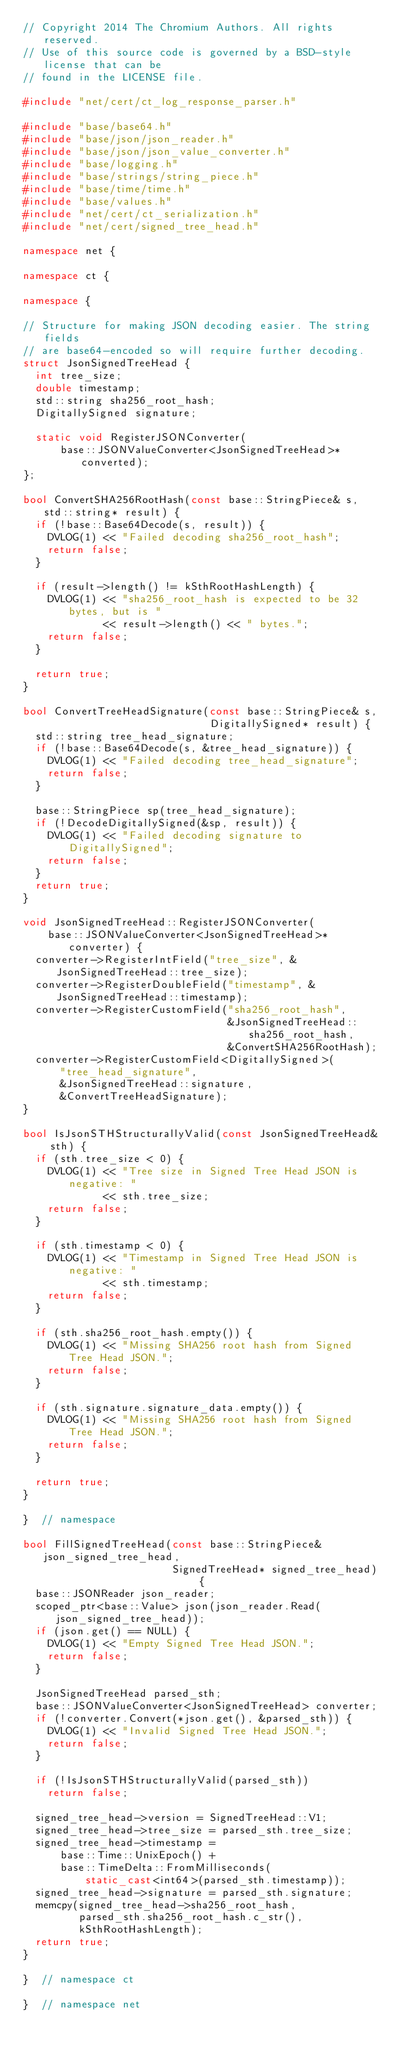Convert code to text. <code><loc_0><loc_0><loc_500><loc_500><_C++_>// Copyright 2014 The Chromium Authors. All rights reserved.
// Use of this source code is governed by a BSD-style license that can be
// found in the LICENSE file.

#include "net/cert/ct_log_response_parser.h"

#include "base/base64.h"
#include "base/json/json_reader.h"
#include "base/json/json_value_converter.h"
#include "base/logging.h"
#include "base/strings/string_piece.h"
#include "base/time/time.h"
#include "base/values.h"
#include "net/cert/ct_serialization.h"
#include "net/cert/signed_tree_head.h"

namespace net {

namespace ct {

namespace {

// Structure for making JSON decoding easier. The string fields
// are base64-encoded so will require further decoding.
struct JsonSignedTreeHead {
  int tree_size;
  double timestamp;
  std::string sha256_root_hash;
  DigitallySigned signature;

  static void RegisterJSONConverter(
      base::JSONValueConverter<JsonSignedTreeHead>* converted);
};

bool ConvertSHA256RootHash(const base::StringPiece& s, std::string* result) {
  if (!base::Base64Decode(s, result)) {
    DVLOG(1) << "Failed decoding sha256_root_hash";
    return false;
  }

  if (result->length() != kSthRootHashLength) {
    DVLOG(1) << "sha256_root_hash is expected to be 32 bytes, but is "
             << result->length() << " bytes.";
    return false;
  }

  return true;
}

bool ConvertTreeHeadSignature(const base::StringPiece& s,
                              DigitallySigned* result) {
  std::string tree_head_signature;
  if (!base::Base64Decode(s, &tree_head_signature)) {
    DVLOG(1) << "Failed decoding tree_head_signature";
    return false;
  }

  base::StringPiece sp(tree_head_signature);
  if (!DecodeDigitallySigned(&sp, result)) {
    DVLOG(1) << "Failed decoding signature to DigitallySigned";
    return false;
  }
  return true;
}

void JsonSignedTreeHead::RegisterJSONConverter(
    base::JSONValueConverter<JsonSignedTreeHead>* converter) {
  converter->RegisterIntField("tree_size", &JsonSignedTreeHead::tree_size);
  converter->RegisterDoubleField("timestamp", &JsonSignedTreeHead::timestamp);
  converter->RegisterCustomField("sha256_root_hash",
                                 &JsonSignedTreeHead::sha256_root_hash,
                                 &ConvertSHA256RootHash);
  converter->RegisterCustomField<DigitallySigned>(
      "tree_head_signature",
      &JsonSignedTreeHead::signature,
      &ConvertTreeHeadSignature);
}

bool IsJsonSTHStructurallyValid(const JsonSignedTreeHead& sth) {
  if (sth.tree_size < 0) {
    DVLOG(1) << "Tree size in Signed Tree Head JSON is negative: "
             << sth.tree_size;
    return false;
  }

  if (sth.timestamp < 0) {
    DVLOG(1) << "Timestamp in Signed Tree Head JSON is negative: "
             << sth.timestamp;
    return false;
  }

  if (sth.sha256_root_hash.empty()) {
    DVLOG(1) << "Missing SHA256 root hash from Signed Tree Head JSON.";
    return false;
  }

  if (sth.signature.signature_data.empty()) {
    DVLOG(1) << "Missing SHA256 root hash from Signed Tree Head JSON.";
    return false;
  }

  return true;
}

}  // namespace

bool FillSignedTreeHead(const base::StringPiece& json_signed_tree_head,
                        SignedTreeHead* signed_tree_head) {
  base::JSONReader json_reader;
  scoped_ptr<base::Value> json(json_reader.Read(json_signed_tree_head));
  if (json.get() == NULL) {
    DVLOG(1) << "Empty Signed Tree Head JSON.";
    return false;
  }

  JsonSignedTreeHead parsed_sth;
  base::JSONValueConverter<JsonSignedTreeHead> converter;
  if (!converter.Convert(*json.get(), &parsed_sth)) {
    DVLOG(1) << "Invalid Signed Tree Head JSON.";
    return false;
  }

  if (!IsJsonSTHStructurallyValid(parsed_sth))
    return false;

  signed_tree_head->version = SignedTreeHead::V1;
  signed_tree_head->tree_size = parsed_sth.tree_size;
  signed_tree_head->timestamp =
      base::Time::UnixEpoch() +
      base::TimeDelta::FromMilliseconds(
          static_cast<int64>(parsed_sth.timestamp));
  signed_tree_head->signature = parsed_sth.signature;
  memcpy(signed_tree_head->sha256_root_hash,
         parsed_sth.sha256_root_hash.c_str(),
         kSthRootHashLength);
  return true;
}

}  // namespace ct

}  // namespace net
</code> 